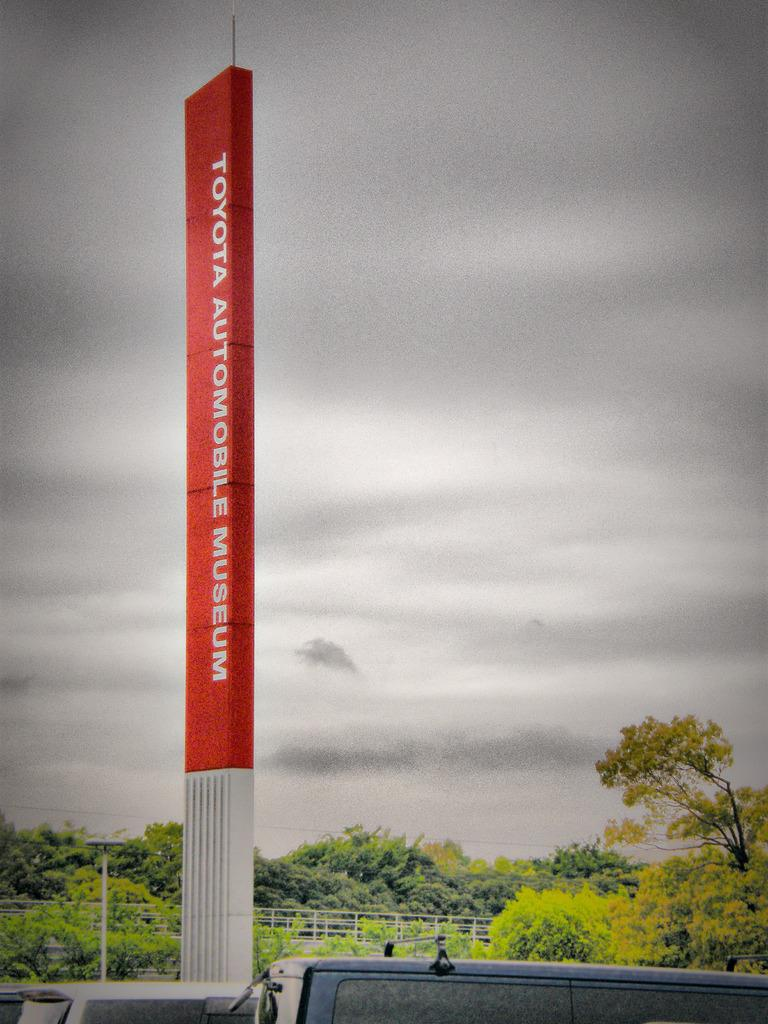<image>
Present a compact description of the photo's key features. Toyota Automobil Museum car lot name on a pole. 